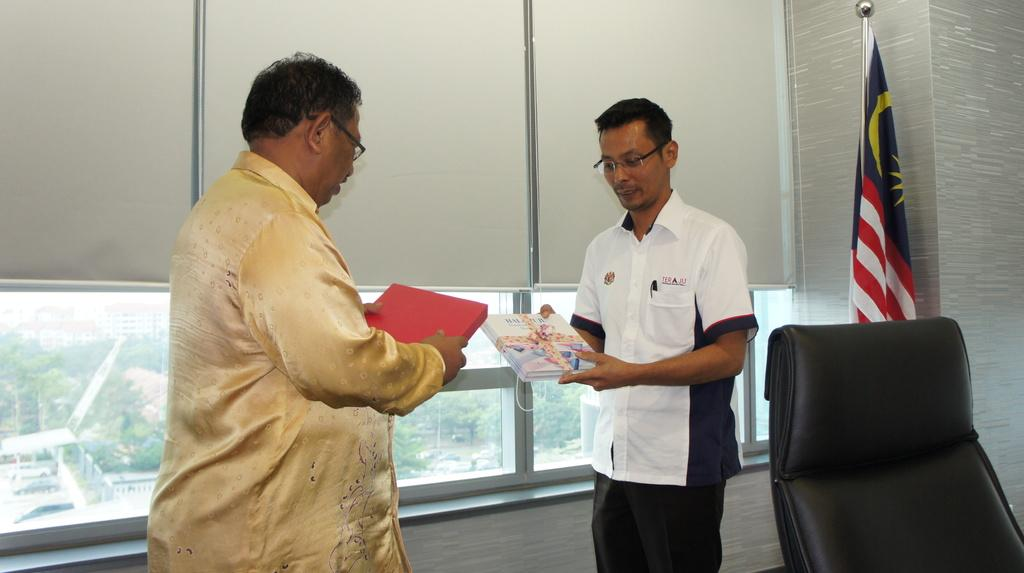How many people are in the image? There are two men in the image. What are the men doing in the image? The men are standing and smiling. What objects are the men holding in the image? The men are holding two books in their hands. What can be seen in the image besides the men and the books? There is a flag and a chair in the image. What is visible in the background of the image? There is a window visible in the background of the image. What type of ice can be seen melting on the floor in the image? There is no ice present in the image; it features two men holding books, a flag, and a chair. Are there any bears visible in the image? No, there are no bears present in the image. 